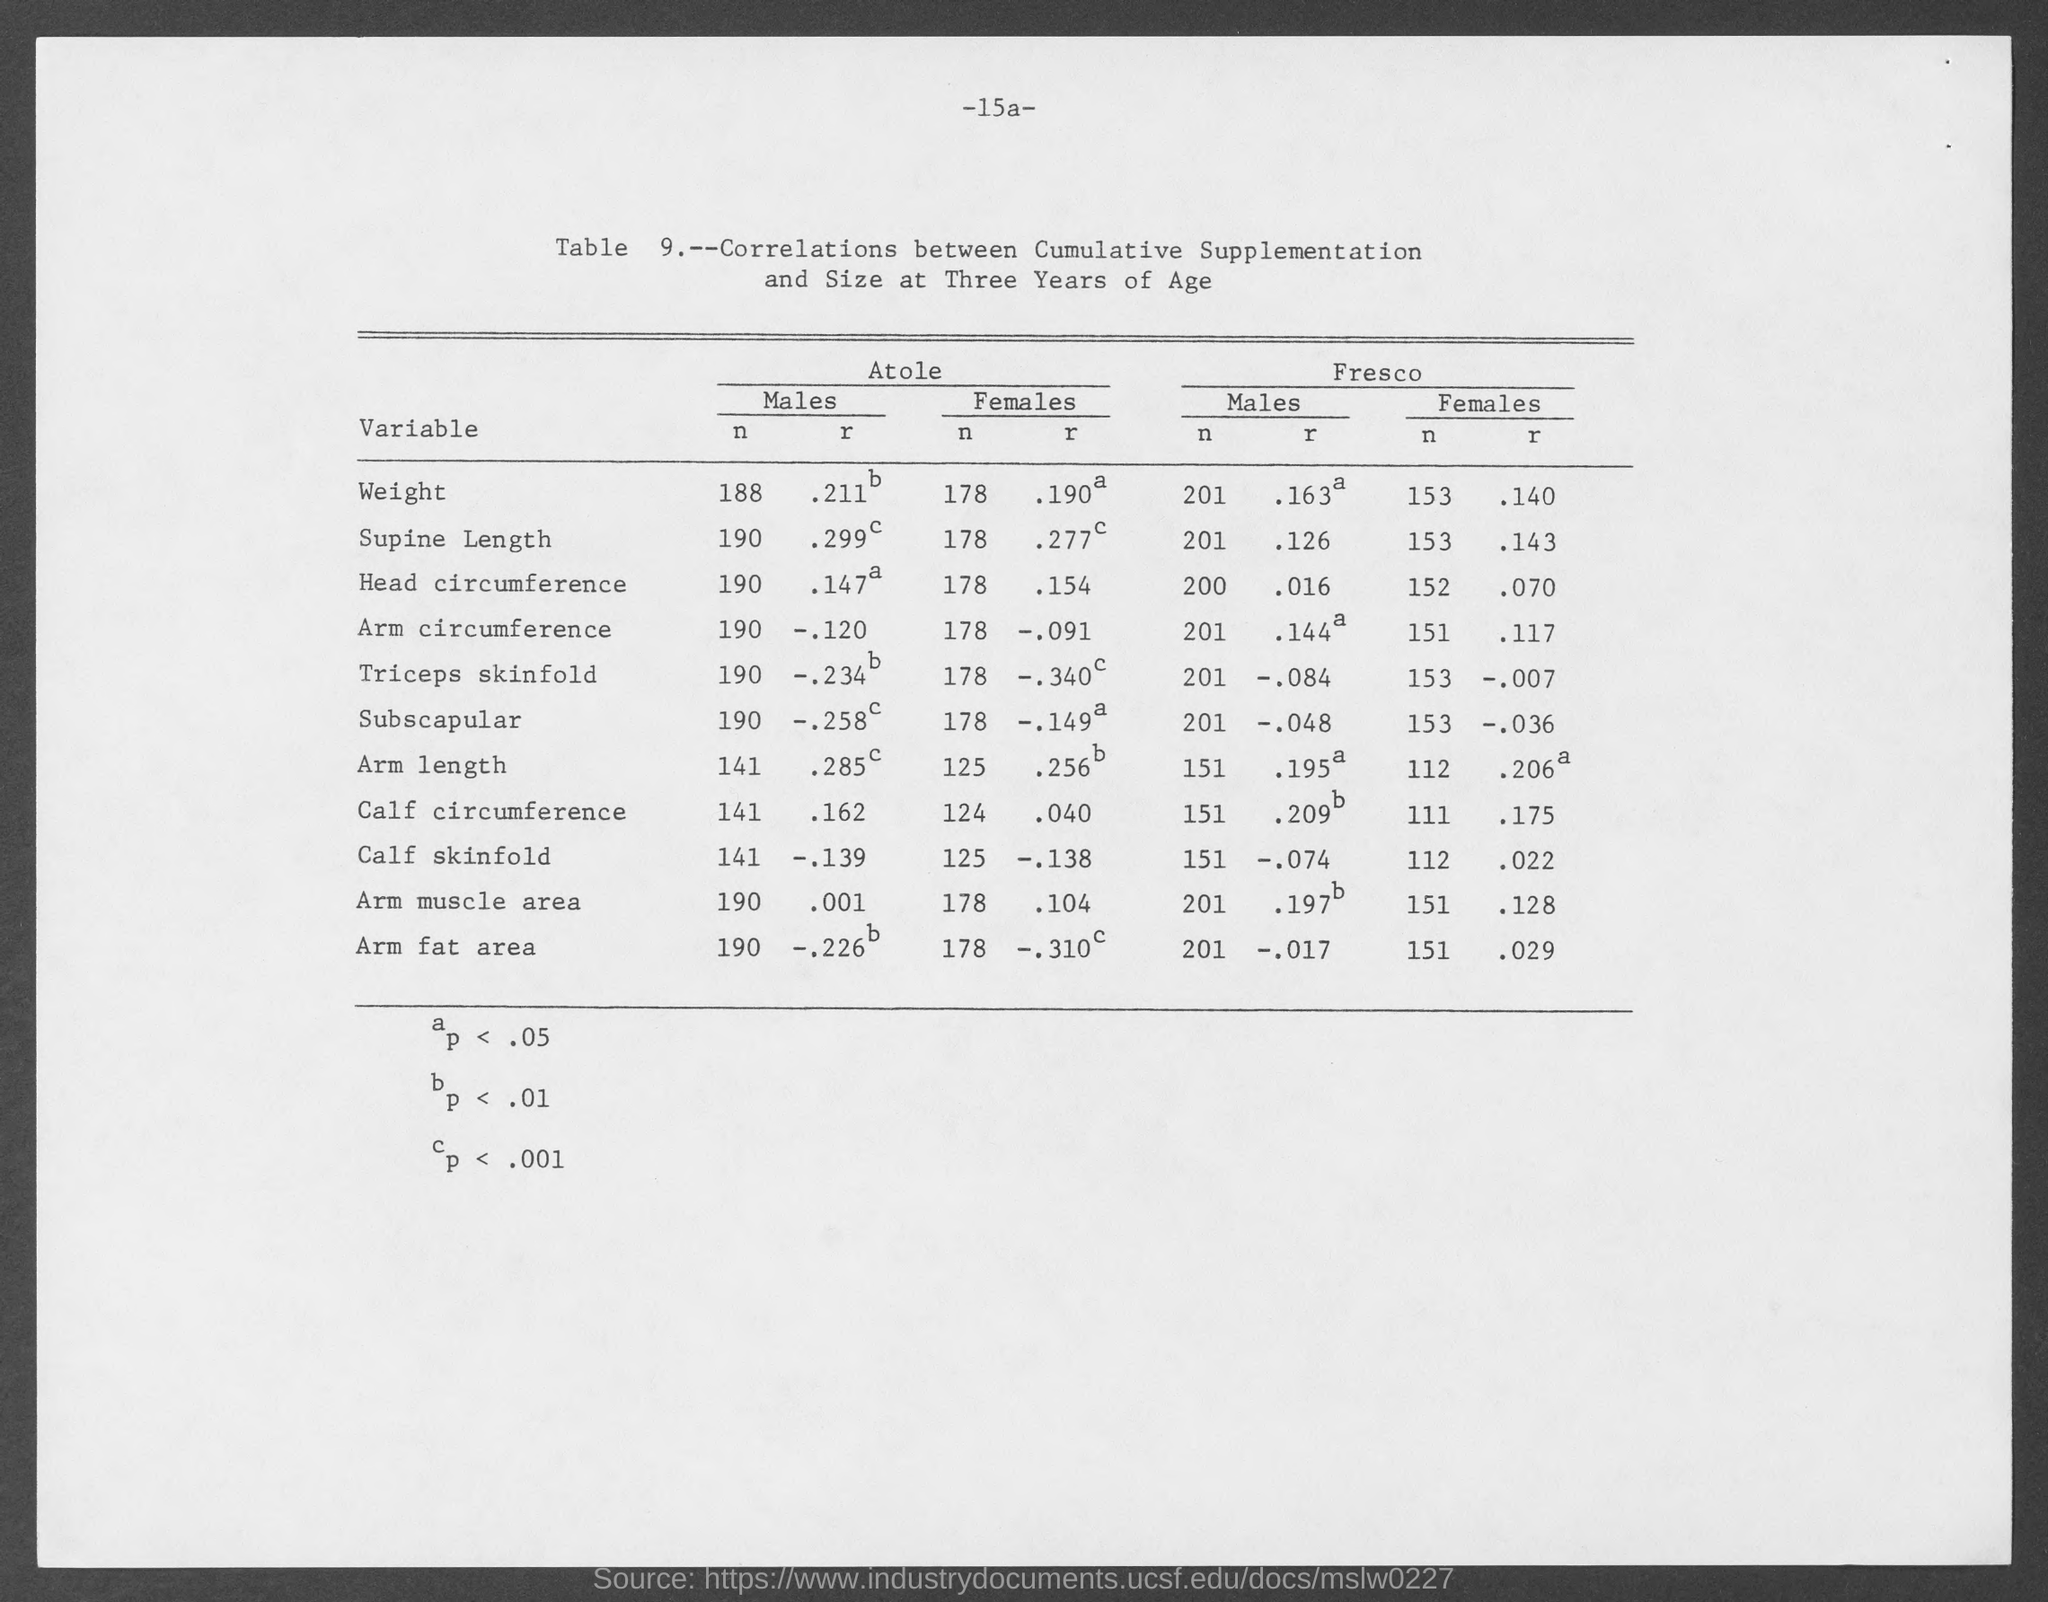Indicate a few pertinent items in this graphic. The page number is 15a. 